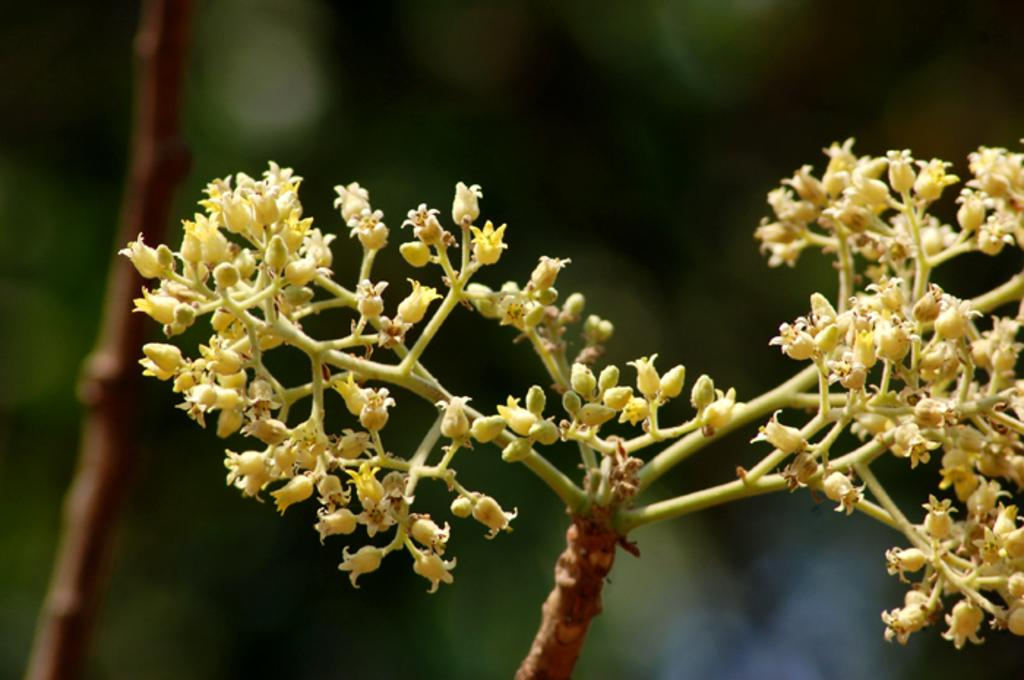What is the main subject of the image? The main subject of the image is a stem of a plant. What can be seen on the stem? There are flowers on the stem. Can you describe the background of the image? The background of the image is blurred. What type of iron can be seen in the image? There is no iron present in the image. Is there a cushion on the stem of the plant in the image? No, there is no cushion on the stem of the plant in the image. 